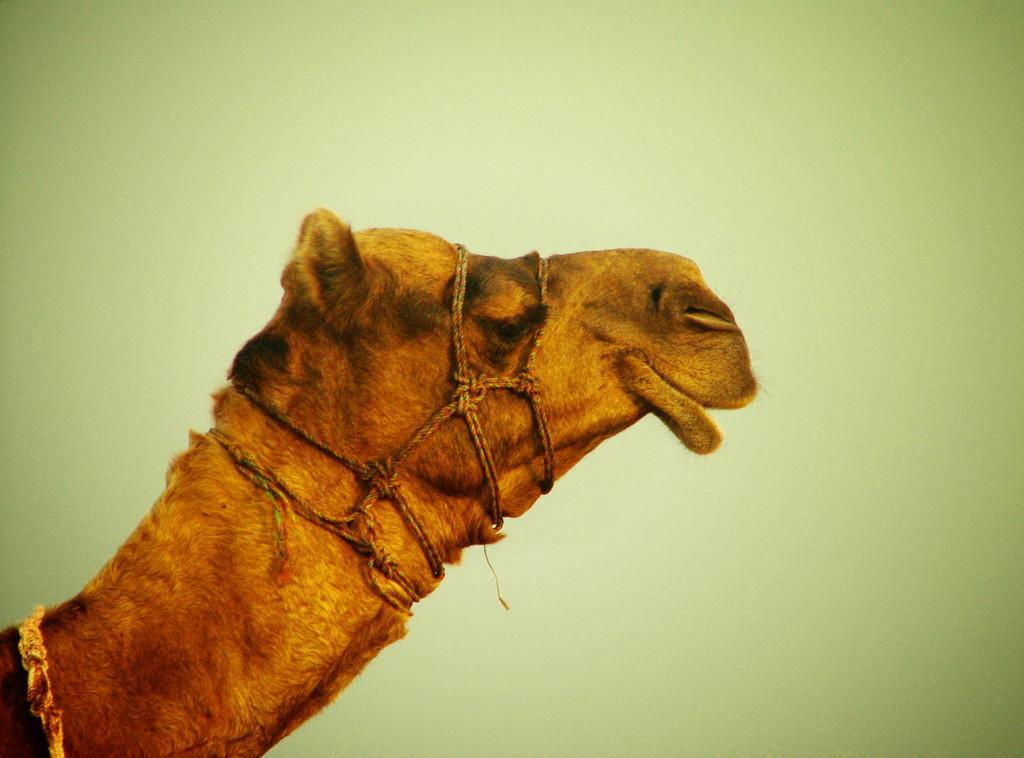Can you describe this image briefly? In this image I can see a camel which is brown and black in color and few ropes tied to it. I can see the green colored background. 